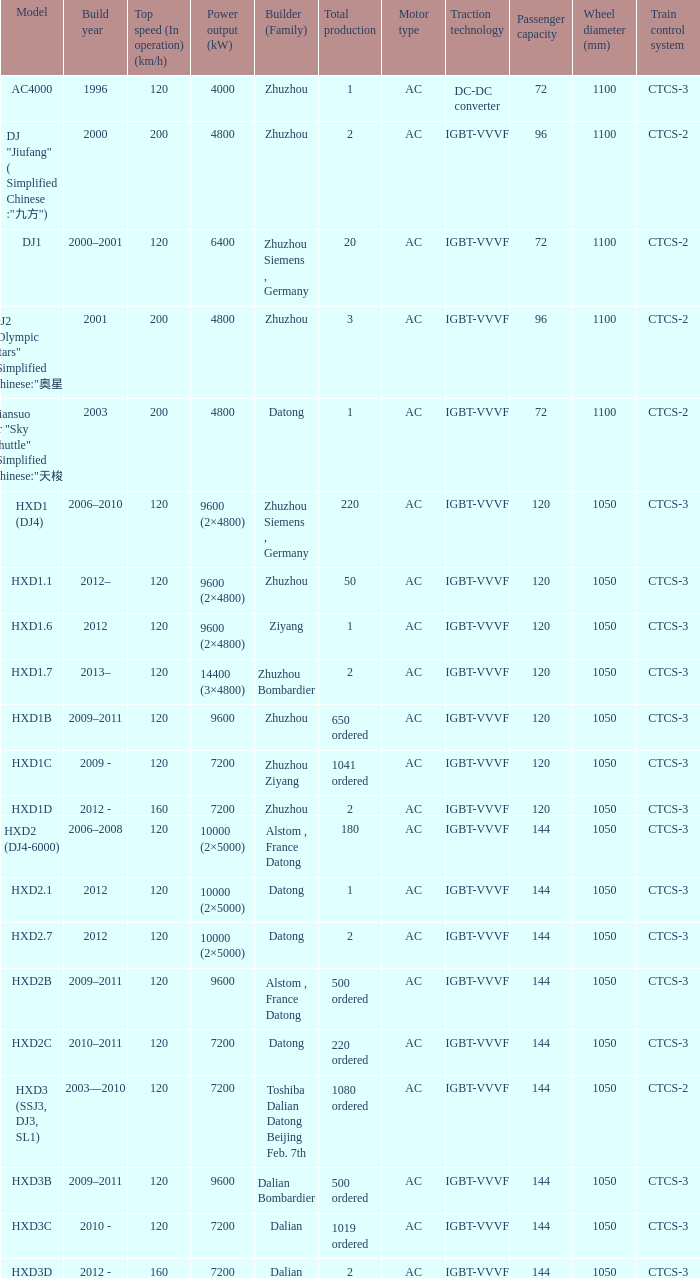What is the power output (kw) of model hxd3d? 7200.0. 